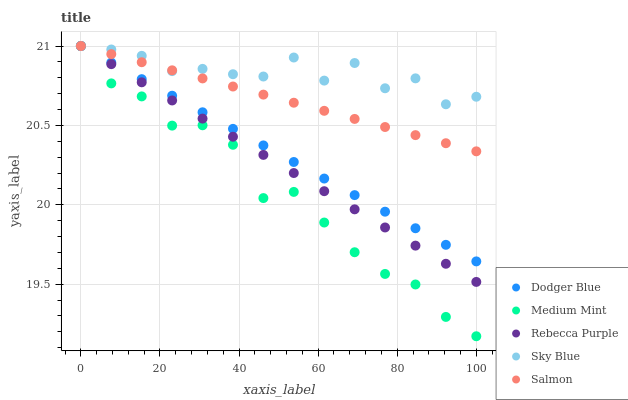Does Medium Mint have the minimum area under the curve?
Answer yes or no. Yes. Does Sky Blue have the maximum area under the curve?
Answer yes or no. Yes. Does Dodger Blue have the minimum area under the curve?
Answer yes or no. No. Does Dodger Blue have the maximum area under the curve?
Answer yes or no. No. Is Salmon the smoothest?
Answer yes or no. Yes. Is Sky Blue the roughest?
Answer yes or no. Yes. Is Dodger Blue the smoothest?
Answer yes or no. No. Is Dodger Blue the roughest?
Answer yes or no. No. Does Medium Mint have the lowest value?
Answer yes or no. Yes. Does Dodger Blue have the lowest value?
Answer yes or no. No. Does Salmon have the highest value?
Answer yes or no. Yes. Does Salmon intersect Dodger Blue?
Answer yes or no. Yes. Is Salmon less than Dodger Blue?
Answer yes or no. No. Is Salmon greater than Dodger Blue?
Answer yes or no. No. 